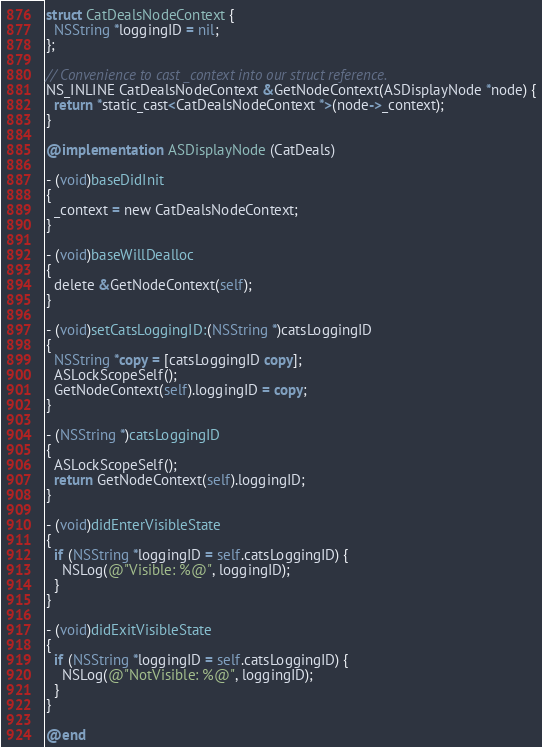Convert code to text. <code><loc_0><loc_0><loc_500><loc_500><_ObjectiveC_>struct CatDealsNodeContext {
  NSString *loggingID = nil;
};

// Convenience to cast _context into our struct reference.
NS_INLINE CatDealsNodeContext &GetNodeContext(ASDisplayNode *node) {
  return *static_cast<CatDealsNodeContext *>(node->_context);
}

@implementation ASDisplayNode (CatDeals)

- (void)baseDidInit
{
  _context = new CatDealsNodeContext;
}

- (void)baseWillDealloc
{
  delete &GetNodeContext(self);
}

- (void)setCatsLoggingID:(NSString *)catsLoggingID
{
  NSString *copy = [catsLoggingID copy];
  ASLockScopeSelf();
  GetNodeContext(self).loggingID = copy;
}

- (NSString *)catsLoggingID
{
  ASLockScopeSelf();
  return GetNodeContext(self).loggingID;
}

- (void)didEnterVisibleState
{
  if (NSString *loggingID = self.catsLoggingID) {
    NSLog(@"Visible: %@", loggingID);
  }
}

- (void)didExitVisibleState
{
  if (NSString *loggingID = self.catsLoggingID) {
    NSLog(@"NotVisible: %@", loggingID);
  }
}

@end
</code> 